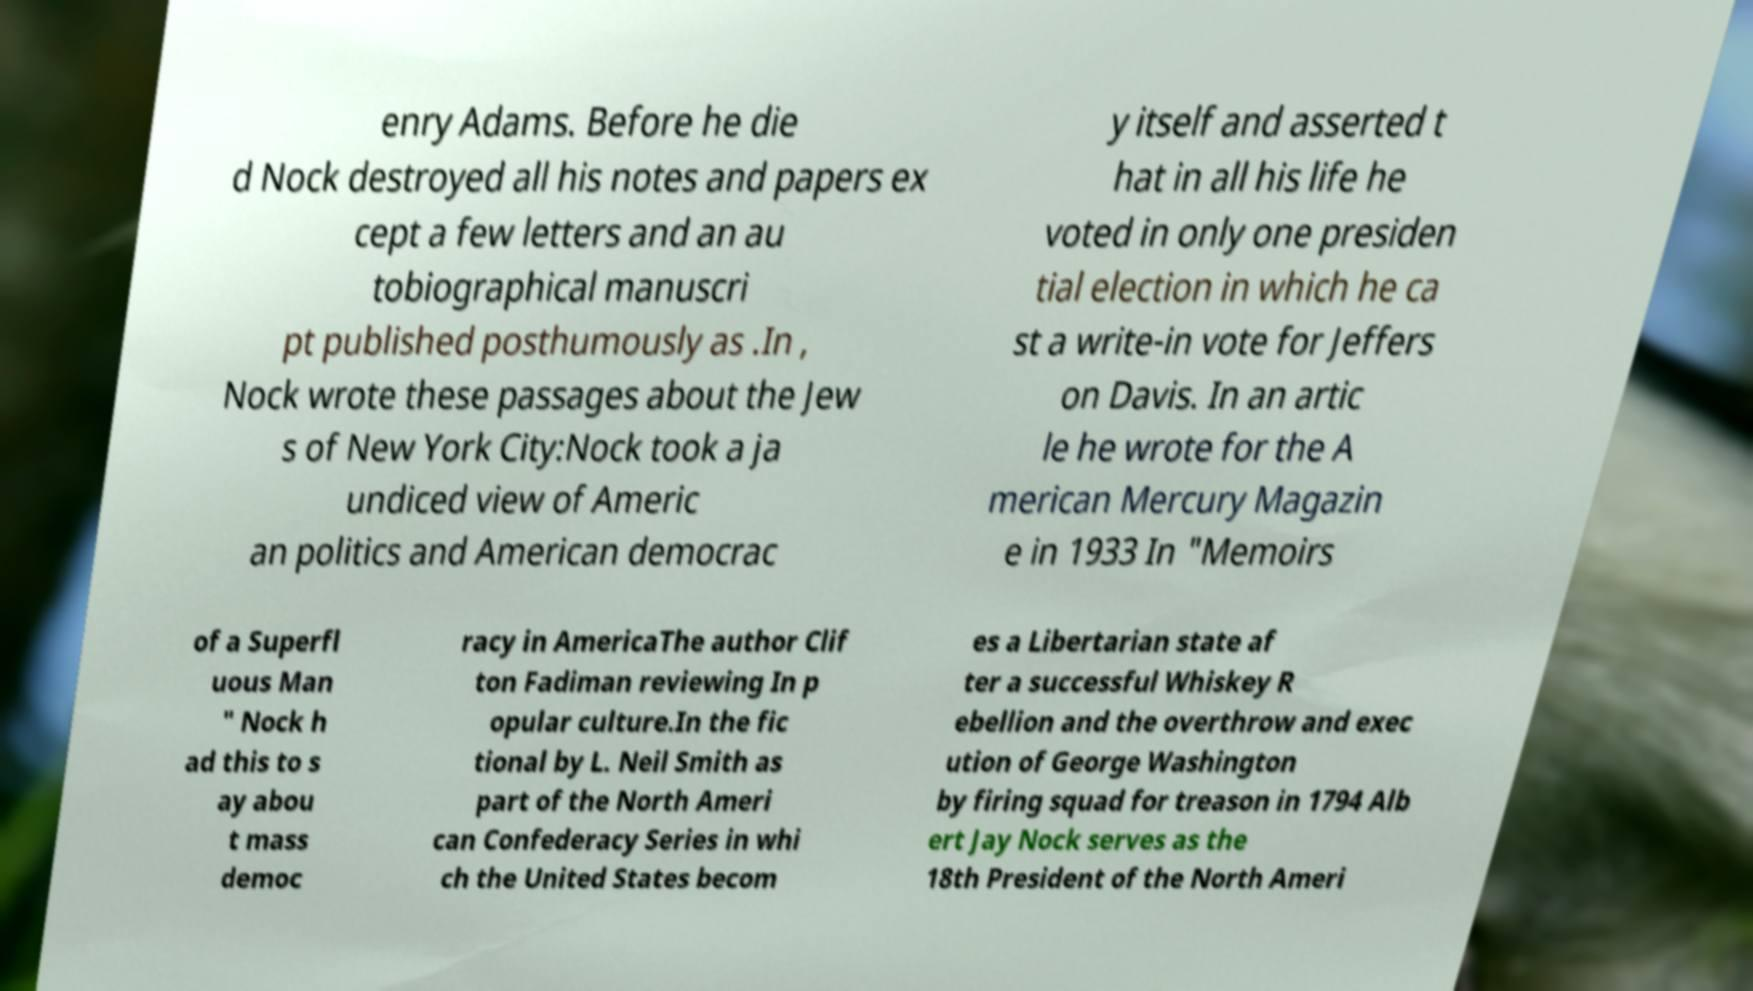There's text embedded in this image that I need extracted. Can you transcribe it verbatim? enry Adams. Before he die d Nock destroyed all his notes and papers ex cept a few letters and an au tobiographical manuscri pt published posthumously as .In , Nock wrote these passages about the Jew s of New York City:Nock took a ja undiced view of Americ an politics and American democrac y itself and asserted t hat in all his life he voted in only one presiden tial election in which he ca st a write-in vote for Jeffers on Davis. In an artic le he wrote for the A merican Mercury Magazin e in 1933 In "Memoirs of a Superfl uous Man " Nock h ad this to s ay abou t mass democ racy in AmericaThe author Clif ton Fadiman reviewing In p opular culture.In the fic tional by L. Neil Smith as part of the North Ameri can Confederacy Series in whi ch the United States becom es a Libertarian state af ter a successful Whiskey R ebellion and the overthrow and exec ution of George Washington by firing squad for treason in 1794 Alb ert Jay Nock serves as the 18th President of the North Ameri 